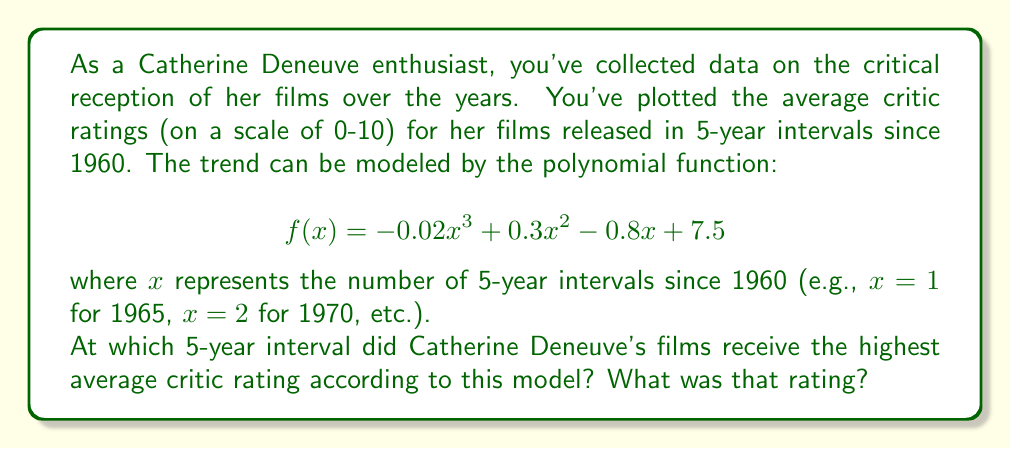Teach me how to tackle this problem. To find the highest point of the polynomial function, we need to follow these steps:

1) First, we find the derivative of the function:
   $$f'(x) = -0.06x^2 + 0.6x - 0.8$$

2) Set the derivative equal to zero to find critical points:
   $$-0.06x^2 + 0.6x - 0.8 = 0$$

3) This is a quadratic equation. We can solve it using the quadratic formula:
   $$x = \frac{-b \pm \sqrt{b^2 - 4ac}}{2a}$$
   where $a=-0.06$, $b=0.6$, and $c=-0.8$

4) Plugging in these values:
   $$x = \frac{-0.6 \pm \sqrt{0.6^2 - 4(-0.06)(-0.8)}}{2(-0.06)}$$
   $$= \frac{-0.6 \pm \sqrt{0.36 - 0.192}}{-0.12}$$
   $$= \frac{-0.6 \pm \sqrt{0.168}}{-0.12}$$
   $$= \frac{-0.6 \pm 0.41}{-0.12}$$

5) This gives us two solutions:
   $$x_1 = \frac{-0.6 + 0.41}{-0.12} \approx 1.58$$
   $$x_2 = \frac{-0.6 - 0.41}{-0.12} \approx 8.42$$

6) The second solution is outside our domain (as it would represent a year beyond 2020), so we focus on $x_1 \approx 1.58$.

7) Rounding to the nearest integer (as we're dealing with 5-year intervals), this corresponds to $x=2$, which represents 1970.

8) To find the rating at this point, we plug $x=2$ into our original function:
   $$f(2) = -0.02(2)^3 + 0.3(2)^2 - 0.8(2) + 7.5$$
   $$= -0.16 + 1.2 - 1.6 + 7.5$$
   $$= 6.94$$

Therefore, the model suggests that Catherine Deneuve's films received the highest average critic rating around 1970, with a rating of approximately 6.94 out of 10.
Answer: The highest average critic rating for Catherine Deneuve's films occurred around 1970 (2nd 5-year interval since 1960) with a rating of approximately 6.94 out of 10. 